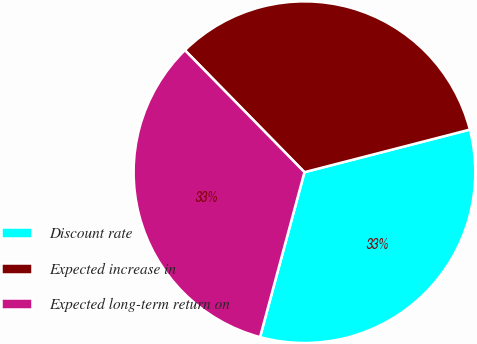Convert chart to OTSL. <chart><loc_0><loc_0><loc_500><loc_500><pie_chart><fcel>Discount rate<fcel>Expected increase in<fcel>Expected long-term return on<nl><fcel>33.2%<fcel>33.33%<fcel>33.47%<nl></chart> 